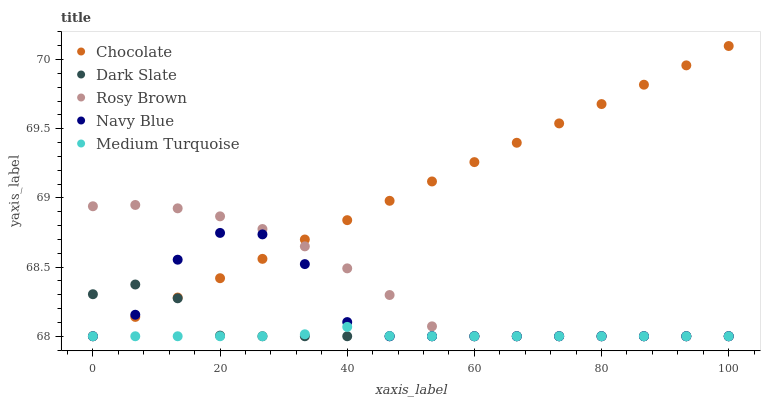Does Medium Turquoise have the minimum area under the curve?
Answer yes or no. Yes. Does Chocolate have the maximum area under the curve?
Answer yes or no. Yes. Does Navy Blue have the minimum area under the curve?
Answer yes or no. No. Does Navy Blue have the maximum area under the curve?
Answer yes or no. No. Is Chocolate the smoothest?
Answer yes or no. Yes. Is Navy Blue the roughest?
Answer yes or no. Yes. Is Rosy Brown the smoothest?
Answer yes or no. No. Is Rosy Brown the roughest?
Answer yes or no. No. Does Dark Slate have the lowest value?
Answer yes or no. Yes. Does Chocolate have the highest value?
Answer yes or no. Yes. Does Navy Blue have the highest value?
Answer yes or no. No. Does Medium Turquoise intersect Chocolate?
Answer yes or no. Yes. Is Medium Turquoise less than Chocolate?
Answer yes or no. No. Is Medium Turquoise greater than Chocolate?
Answer yes or no. No. 